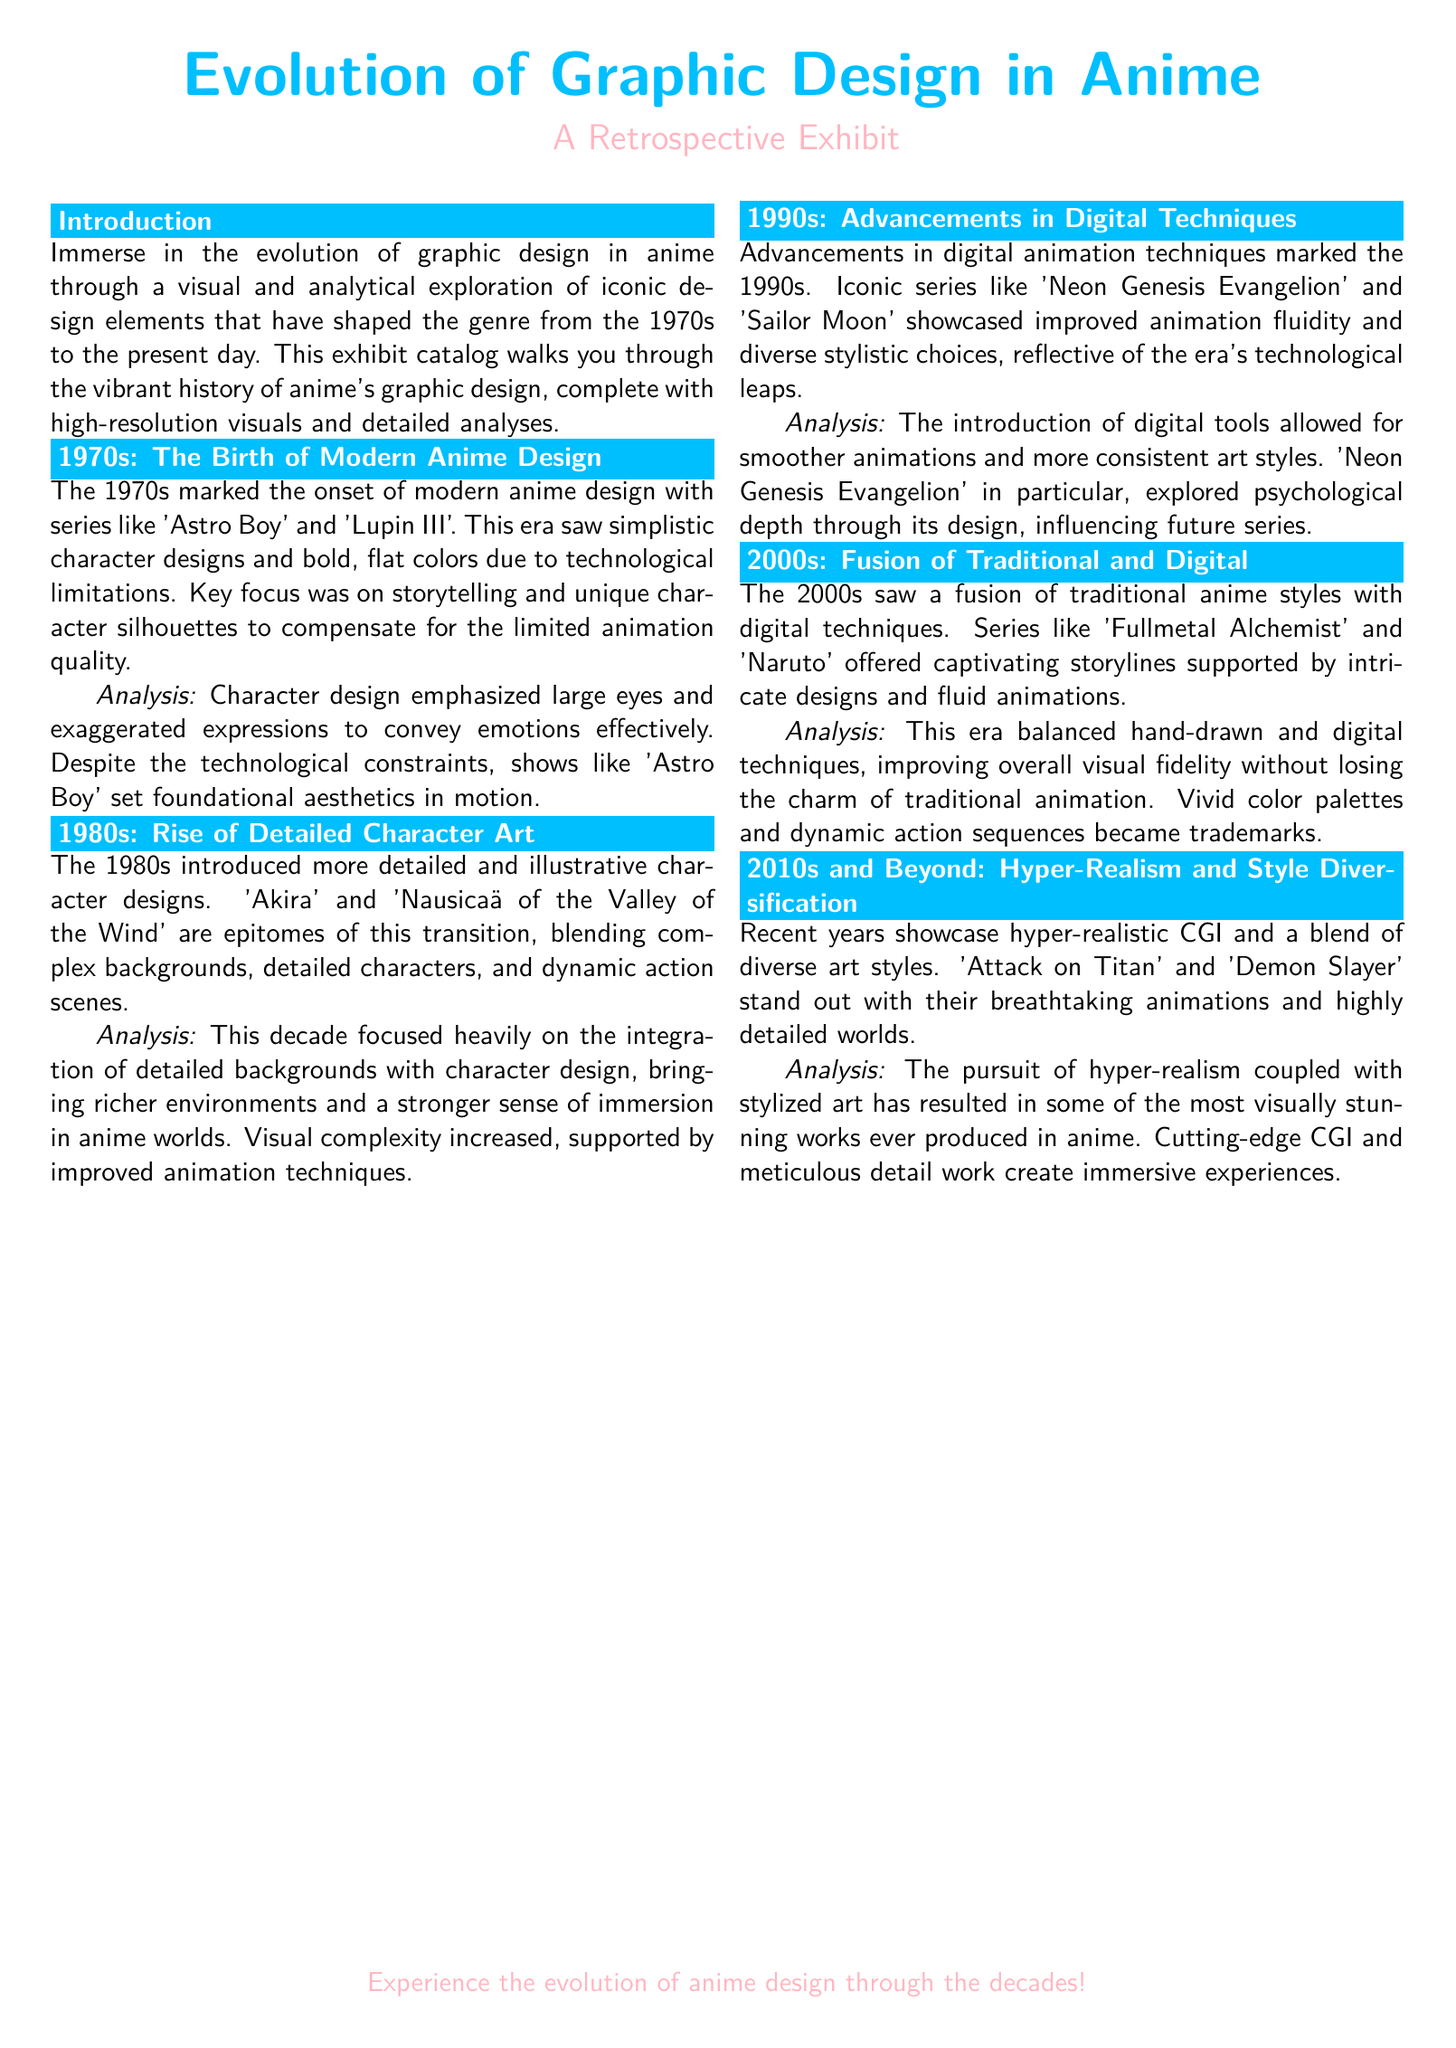What is the focus of the exhibit? The focus of the exhibit is the visual and analytical exploration of iconic design elements that have shaped the genre of anime.
Answer: visual and analytical exploration What decade introduced hyper-realistic CGI? The decade that introduced hyper-realistic CGI is the 2010s.
Answer: 2010s Which series is highlighted for its detailed environments in the 1980s? The series highlighted for its detailed environments in the 1980s is 'Akira'.
Answer: Akira What improves the fluidity of animation in the 1990s? The improvement in fluidity of animation in the 1990s is due to advancements in digital animation techniques.
Answer: advancements in digital animation techniques What was the character design emphasis in the 1970s? The character design emphasis in the 1970s was on large eyes and exaggerated expressions.
Answer: large eyes and exaggerated expressions Which series is known for exploring psychological depth through its design? The series known for exploring psychological depth through its design is 'Neon Genesis Evangelion'.
Answer: Neon Genesis Evangelion What is a trademark of the 2000s in anime? A trademark of the 2000s in anime is the balance between hand-drawn and digital techniques.
Answer: balance between hand-drawn and digital techniques What is the title of the exhibit catalog? The title of the exhibit catalog is 'Evolution of Graphic Design in Anime'.
Answer: Evolution of Graphic Design in Anime 